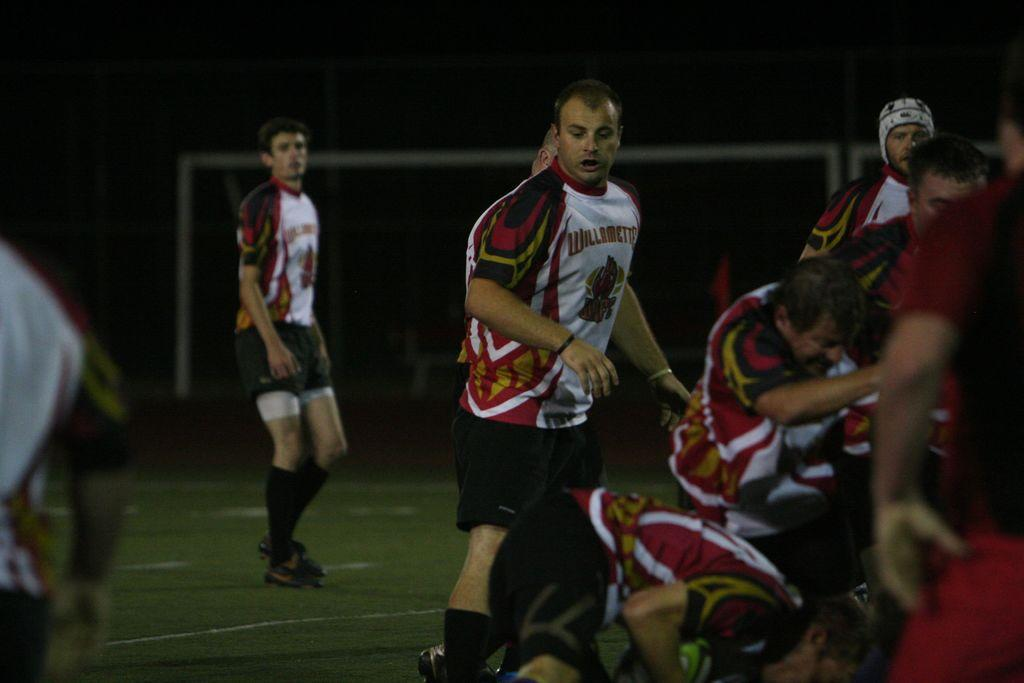<image>
Share a concise interpretation of the image provided. Teammates stand on a field in Willamette jerseys. 